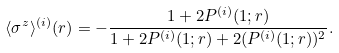<formula> <loc_0><loc_0><loc_500><loc_500>\langle \sigma ^ { z } \rangle ^ { ( i ) } ( r ) = - \frac { 1 + 2 P ^ { ( i ) } ( 1 ; r ) } { 1 + 2 P ^ { ( i ) } ( 1 ; r ) + 2 ( P ^ { ( i ) } ( 1 ; r ) ) ^ { 2 } } .</formula> 